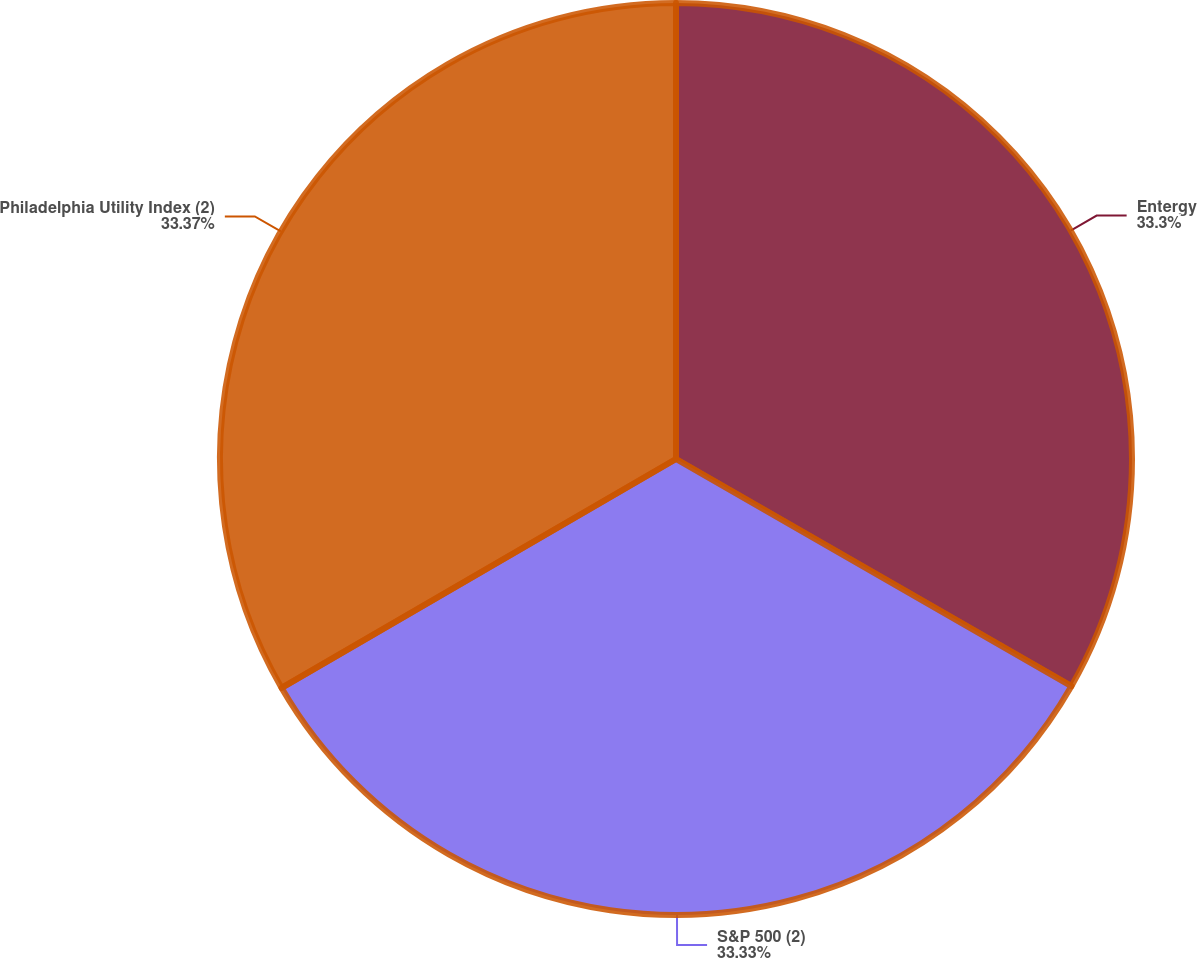Convert chart to OTSL. <chart><loc_0><loc_0><loc_500><loc_500><pie_chart><fcel>Entergy<fcel>S&P 500 (2)<fcel>Philadelphia Utility Index (2)<nl><fcel>33.3%<fcel>33.33%<fcel>33.37%<nl></chart> 